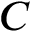<formula> <loc_0><loc_0><loc_500><loc_500>C</formula> 